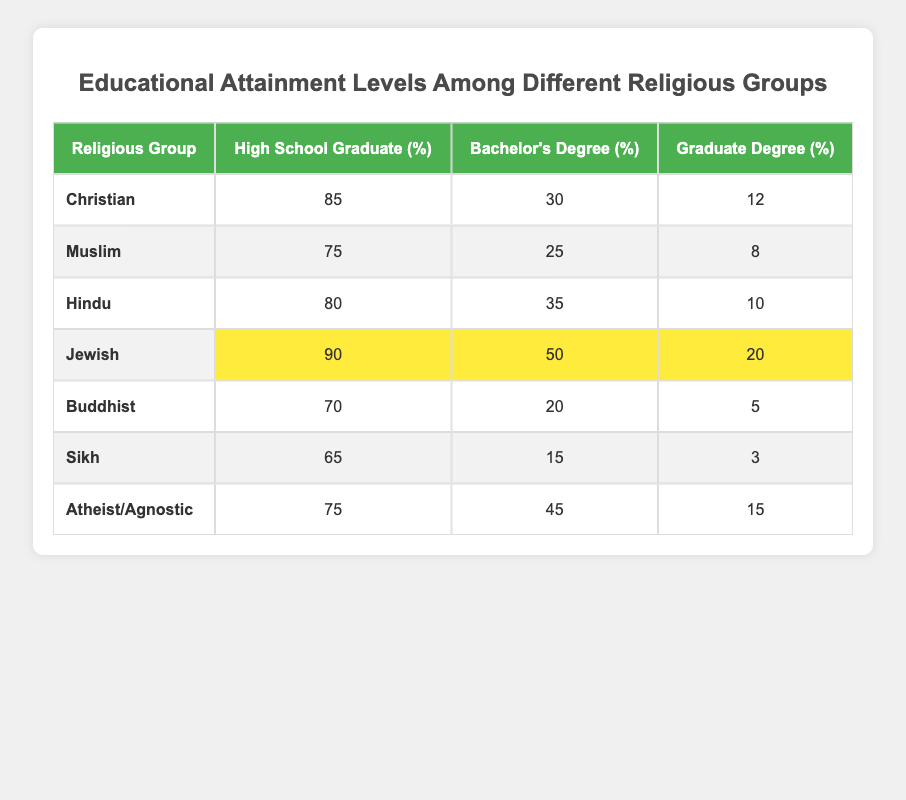What percentage of Jews are high school graduates? From the table, the percentage of high school graduates among Jews is listed as 90%.
Answer: 90% Which group has the highest percentage of individuals with a Bachelor's degree? Upon examining the table, Jews have the highest percentage of Bachelor's degree holders at 50%.
Answer: 50% What is the average percentage of high school graduates across all groups? To calculate the average, add all the percentages of high school graduates: 85 + 75 + 80 + 90 + 70 + 65 + 75 = 540. Then divide by the total number of groups (7): 540 / 7 = 77.14.
Answer: 77.14 Is it true that Atheists/Agnostics have more individuals with Graduate degrees than Muslims? The table indicates that Atheists/Agnostics have 15% with Graduate degrees while Muslims have 8%. Since 15% is greater than 8%, the statement is true.
Answer: Yes What is the difference in the percentage of Bachelor’s degrees between Hindus and Sikhs? From the table, Hindus have 35% with Bachelor's degrees and Sikhs have 15%. The difference is 35 - 15 = 20%.
Answer: 20% Which group has the lowest percentage of high school graduates, and what is that percentage? Looking at the table, the group with the lowest percentage of high school graduates is Sikhs, with just 65%.
Answer: 65% What is the sum of the percentages of Graduate degrees for all groups? To find the sum of the Graduate degrees, add the percentages: 12 + 8 + 10 + 20 + 5 + 3 + 15 = 73.
Answer: 73 How many groups have over 80% of high school graduates? From the table, Christian (85%), Hindu (80%), and Jewish (90%) groups have over 80% of high school graduates. Therefore, there are three groups.
Answer: 3 